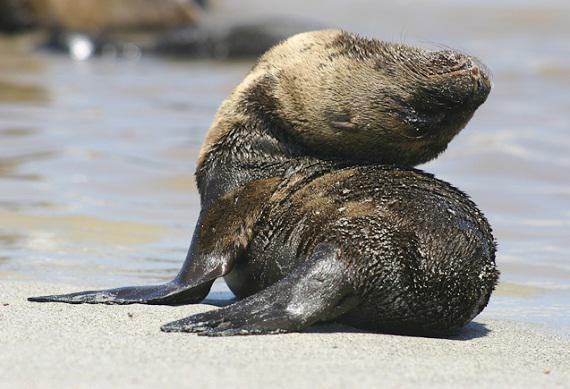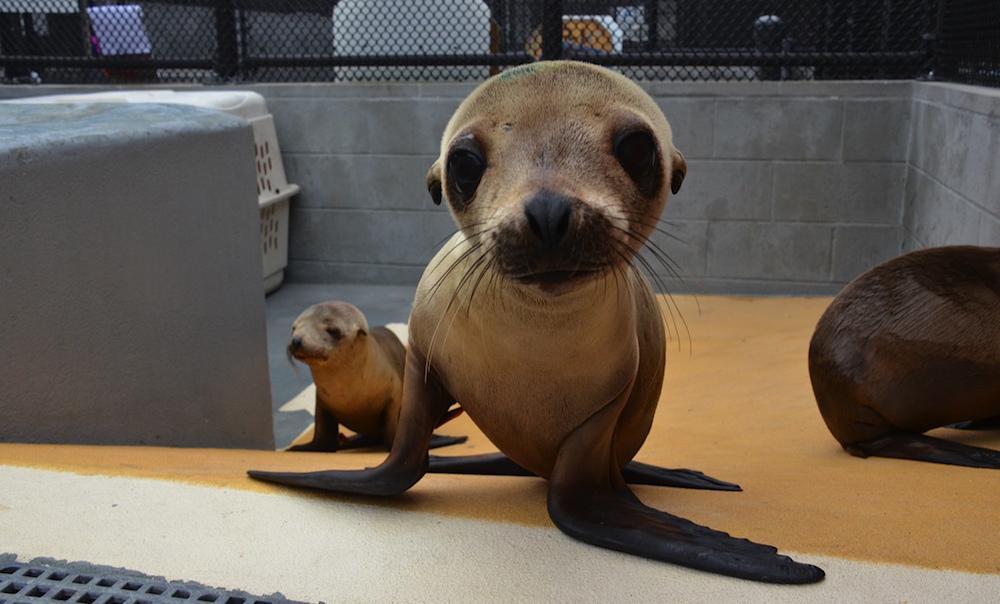The first image is the image on the left, the second image is the image on the right. For the images displayed, is the sentence "An adult seal extends its neck to nuzzle a baby seal with its nose in at least one image." factually correct? Answer yes or no. No. The first image is the image on the left, the second image is the image on the right. For the images displayed, is the sentence "Both images show a adult seal with a baby seal." factually correct? Answer yes or no. No. 